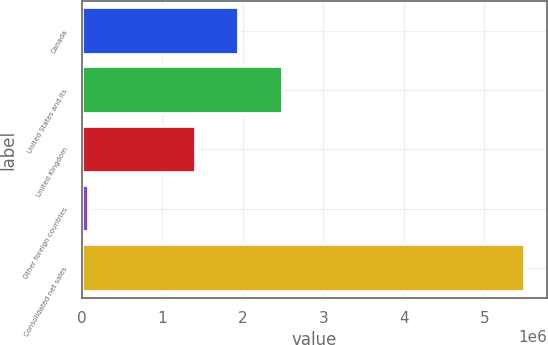<chart> <loc_0><loc_0><loc_500><loc_500><bar_chart><fcel>Canada<fcel>United States and its<fcel>United Kingdom<fcel>Other foreign countries<fcel>Consolidated net sales<nl><fcel>1.95961e+06<fcel>2.50082e+06<fcel>1.41841e+06<fcel>94861<fcel>5.50691e+06<nl></chart> 